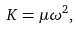Convert formula to latex. <formula><loc_0><loc_0><loc_500><loc_500>K = \mu \omega ^ { 2 } ,</formula> 